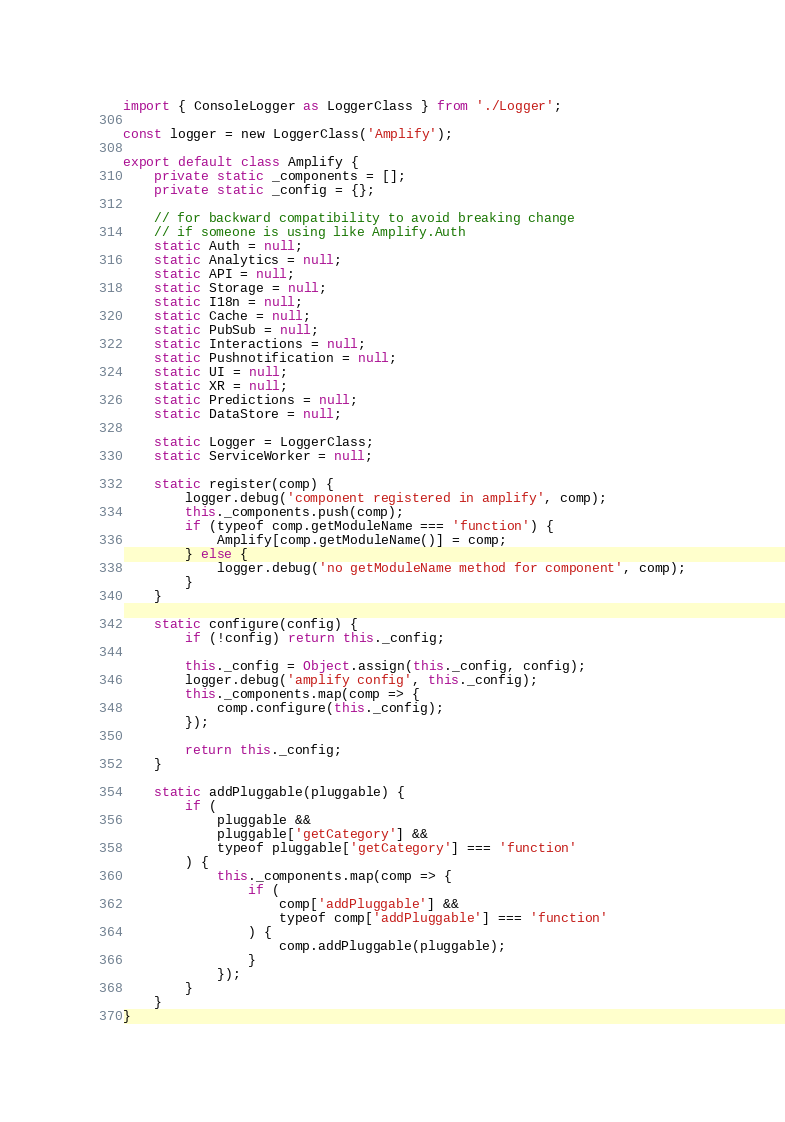Convert code to text. <code><loc_0><loc_0><loc_500><loc_500><_TypeScript_>import { ConsoleLogger as LoggerClass } from './Logger';

const logger = new LoggerClass('Amplify');

export default class Amplify {
	private static _components = [];
	private static _config = {};

	// for backward compatibility to avoid breaking change
	// if someone is using like Amplify.Auth
	static Auth = null;
	static Analytics = null;
	static API = null;
	static Storage = null;
	static I18n = null;
	static Cache = null;
	static PubSub = null;
	static Interactions = null;
	static Pushnotification = null;
	static UI = null;
	static XR = null;
	static Predictions = null;
	static DataStore = null;

	static Logger = LoggerClass;
	static ServiceWorker = null;

	static register(comp) {
		logger.debug('component registered in amplify', comp);
		this._components.push(comp);
		if (typeof comp.getModuleName === 'function') {
			Amplify[comp.getModuleName()] = comp;
		} else {
			logger.debug('no getModuleName method for component', comp);
		}
	}

	static configure(config) {
		if (!config) return this._config;

		this._config = Object.assign(this._config, config);
		logger.debug('amplify config', this._config);
		this._components.map(comp => {
			comp.configure(this._config);
		});

		return this._config;
	}

	static addPluggable(pluggable) {
		if (
			pluggable &&
			pluggable['getCategory'] &&
			typeof pluggable['getCategory'] === 'function'
		) {
			this._components.map(comp => {
				if (
					comp['addPluggable'] &&
					typeof comp['addPluggable'] === 'function'
				) {
					comp.addPluggable(pluggable);
				}
			});
		}
	}
}
</code> 